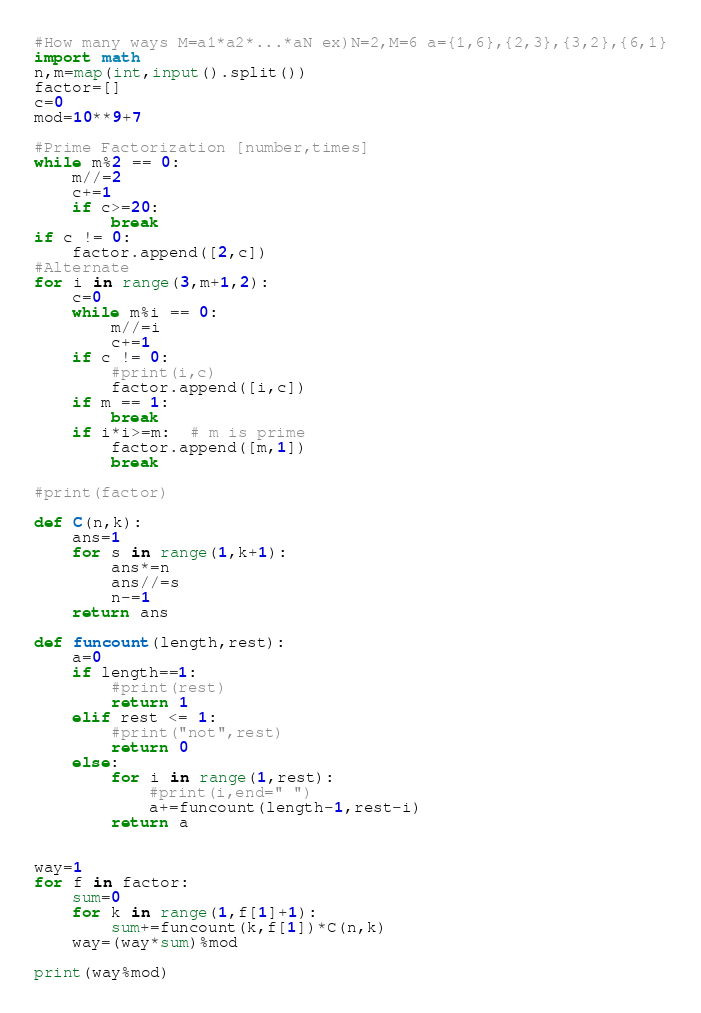Convert code to text. <code><loc_0><loc_0><loc_500><loc_500><_Python_>#How many ways M=a1*a2*...*aN ex)N=2,M=6 a={1,6},{2,3},{3,2},{6,1}
import math
n,m=map(int,input().split())
factor=[]
c=0
mod=10**9+7

#Prime Factorization [number,times]
while m%2 == 0:
    m//=2
    c+=1
    if c>=20:
        break
if c != 0:
    factor.append([2,c])
#Alternate
for i in range(3,m+1,2):
    c=0
    while m%i == 0:
        m//=i
        c+=1
    if c != 0:
        #print(i,c)
        factor.append([i,c])
    if m == 1:
        break
    if i*i>=m:  # m is prime
        factor.append([m,1])
        break
        
#print(factor)

def C(n,k):
    ans=1
    for s in range(1,k+1):
        ans*=n
        ans//=s
        n-=1
    return ans

def funcount(length,rest):
    a=0
    if length==1:
        #print(rest)
        return 1
    elif rest <= 1:
        #print("not",rest)
        return 0
    else:
        for i in range(1,rest):
            #print(i,end=" ")
            a+=funcount(length-1,rest-i)
        return a


way=1
for f in factor:
    sum=0
    for k in range(1,f[1]+1):
        sum+=funcount(k,f[1])*C(n,k)
    way=(way*sum)%mod
    
print(way%mod)</code> 